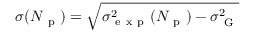Convert formula to latex. <formula><loc_0><loc_0><loc_500><loc_500>\sigma ( N _ { p } ) = \sqrt { \sigma _ { e x p } ^ { 2 } ( N _ { p } ) - \sigma _ { G } ^ { 2 } }</formula> 